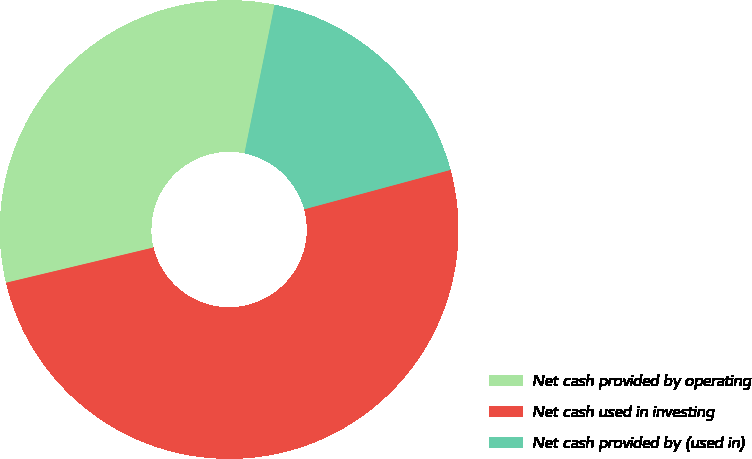Convert chart. <chart><loc_0><loc_0><loc_500><loc_500><pie_chart><fcel>Net cash provided by operating<fcel>Net cash used in investing<fcel>Net cash provided by (used in)<nl><fcel>31.92%<fcel>50.46%<fcel>17.63%<nl></chart> 